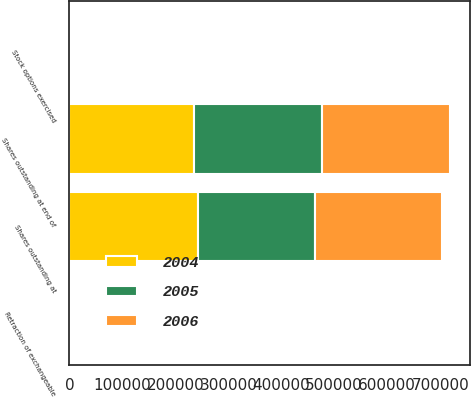Convert chart to OTSL. <chart><loc_0><loc_0><loc_500><loc_500><stacked_bar_chart><ecel><fcel>Shares outstanding at<fcel>Retraction of exchangeable<fcel>Stock options exercised<fcel>Shares outstanding at end of<nl><fcel>2004<fcel>243138<fcel>57<fcel>3651<fcel>236020<nl><fcel>2006<fcel>240361<fcel>66<fcel>2885<fcel>243138<nl><fcel>2005<fcel>220201<fcel>182<fcel>3302<fcel>240361<nl></chart> 